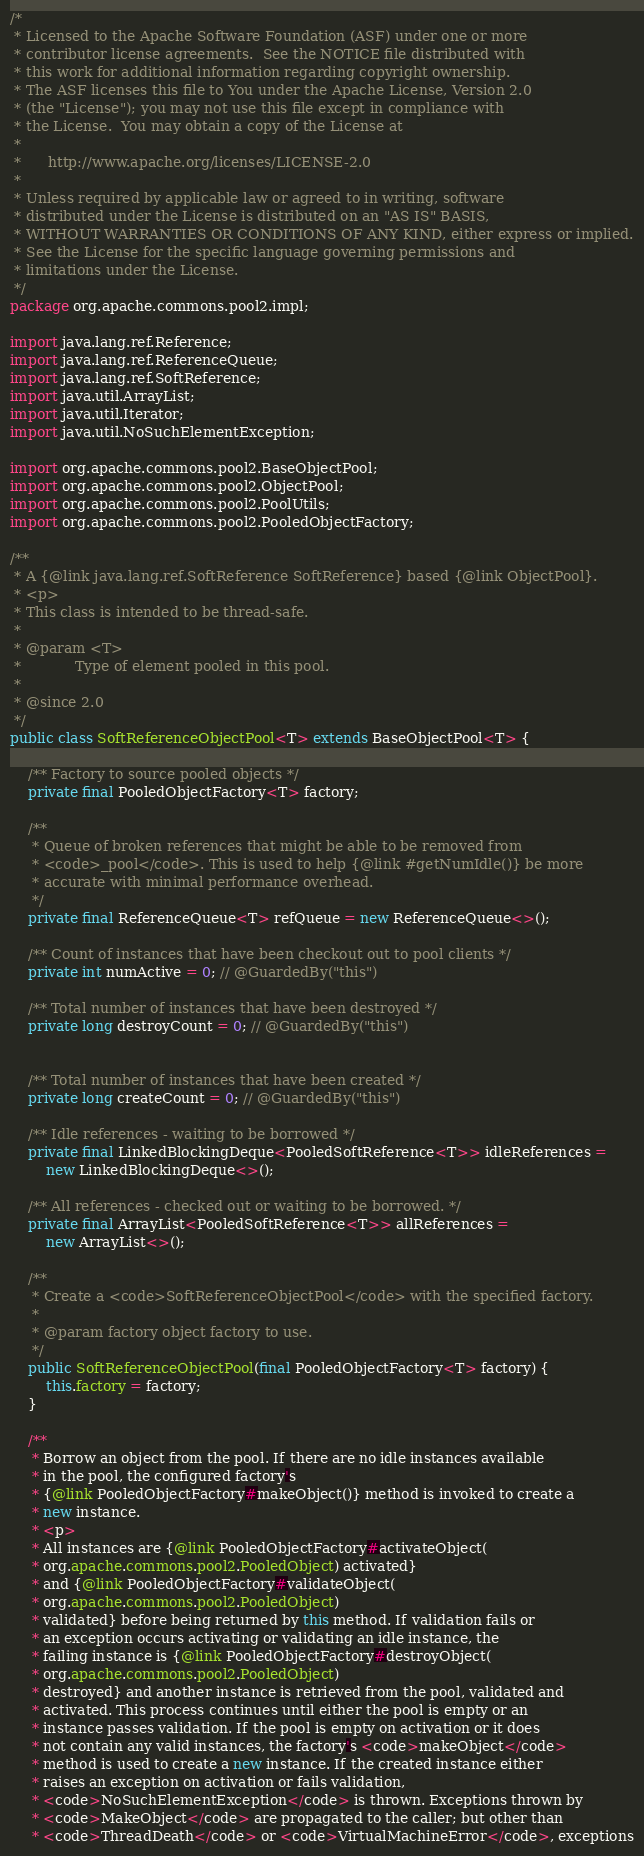Convert code to text. <code><loc_0><loc_0><loc_500><loc_500><_Java_>/*
 * Licensed to the Apache Software Foundation (ASF) under one or more
 * contributor license agreements.  See the NOTICE file distributed with
 * this work for additional information regarding copyright ownership.
 * The ASF licenses this file to You under the Apache License, Version 2.0
 * (the "License"); you may not use this file except in compliance with
 * the License.  You may obtain a copy of the License at
 *
 *      http://www.apache.org/licenses/LICENSE-2.0
 *
 * Unless required by applicable law or agreed to in writing, software
 * distributed under the License is distributed on an "AS IS" BASIS,
 * WITHOUT WARRANTIES OR CONDITIONS OF ANY KIND, either express or implied.
 * See the License for the specific language governing permissions and
 * limitations under the License.
 */
package org.apache.commons.pool2.impl;

import java.lang.ref.Reference;
import java.lang.ref.ReferenceQueue;
import java.lang.ref.SoftReference;
import java.util.ArrayList;
import java.util.Iterator;
import java.util.NoSuchElementException;

import org.apache.commons.pool2.BaseObjectPool;
import org.apache.commons.pool2.ObjectPool;
import org.apache.commons.pool2.PoolUtils;
import org.apache.commons.pool2.PooledObjectFactory;

/**
 * A {@link java.lang.ref.SoftReference SoftReference} based {@link ObjectPool}.
 * <p>
 * This class is intended to be thread-safe.
 *
 * @param <T>
 *            Type of element pooled in this pool.
 *
 * @since 2.0
 */
public class SoftReferenceObjectPool<T> extends BaseObjectPool<T> {

    /** Factory to source pooled objects */
    private final PooledObjectFactory<T> factory;

    /**
     * Queue of broken references that might be able to be removed from
     * <code>_pool</code>. This is used to help {@link #getNumIdle()} be more
     * accurate with minimal performance overhead.
     */
    private final ReferenceQueue<T> refQueue = new ReferenceQueue<>();

    /** Count of instances that have been checkout out to pool clients */
    private int numActive = 0; // @GuardedBy("this")

    /** Total number of instances that have been destroyed */
    private long destroyCount = 0; // @GuardedBy("this")


    /** Total number of instances that have been created */
    private long createCount = 0; // @GuardedBy("this")

    /** Idle references - waiting to be borrowed */
    private final LinkedBlockingDeque<PooledSoftReference<T>> idleReferences =
        new LinkedBlockingDeque<>();

    /** All references - checked out or waiting to be borrowed. */
    private final ArrayList<PooledSoftReference<T>> allReferences =
        new ArrayList<>();

    /**
     * Create a <code>SoftReferenceObjectPool</code> with the specified factory.
     *
     * @param factory object factory to use.
     */
    public SoftReferenceObjectPool(final PooledObjectFactory<T> factory) {
        this.factory = factory;
    }

    /**
     * Borrow an object from the pool. If there are no idle instances available
     * in the pool, the configured factory's
     * {@link PooledObjectFactory#makeObject()} method is invoked to create a
     * new instance.
     * <p>
     * All instances are {@link PooledObjectFactory#activateObject(
     * org.apache.commons.pool2.PooledObject) activated}
     * and {@link PooledObjectFactory#validateObject(
     * org.apache.commons.pool2.PooledObject)
     * validated} before being returned by this method. If validation fails or
     * an exception occurs activating or validating an idle instance, the
     * failing instance is {@link PooledObjectFactory#destroyObject(
     * org.apache.commons.pool2.PooledObject)
     * destroyed} and another instance is retrieved from the pool, validated and
     * activated. This process continues until either the pool is empty or an
     * instance passes validation. If the pool is empty on activation or it does
     * not contain any valid instances, the factory's <code>makeObject</code>
     * method is used to create a new instance. If the created instance either
     * raises an exception on activation or fails validation,
     * <code>NoSuchElementException</code> is thrown. Exceptions thrown by
     * <code>MakeObject</code> are propagated to the caller; but other than
     * <code>ThreadDeath</code> or <code>VirtualMachineError</code>, exceptions</code> 